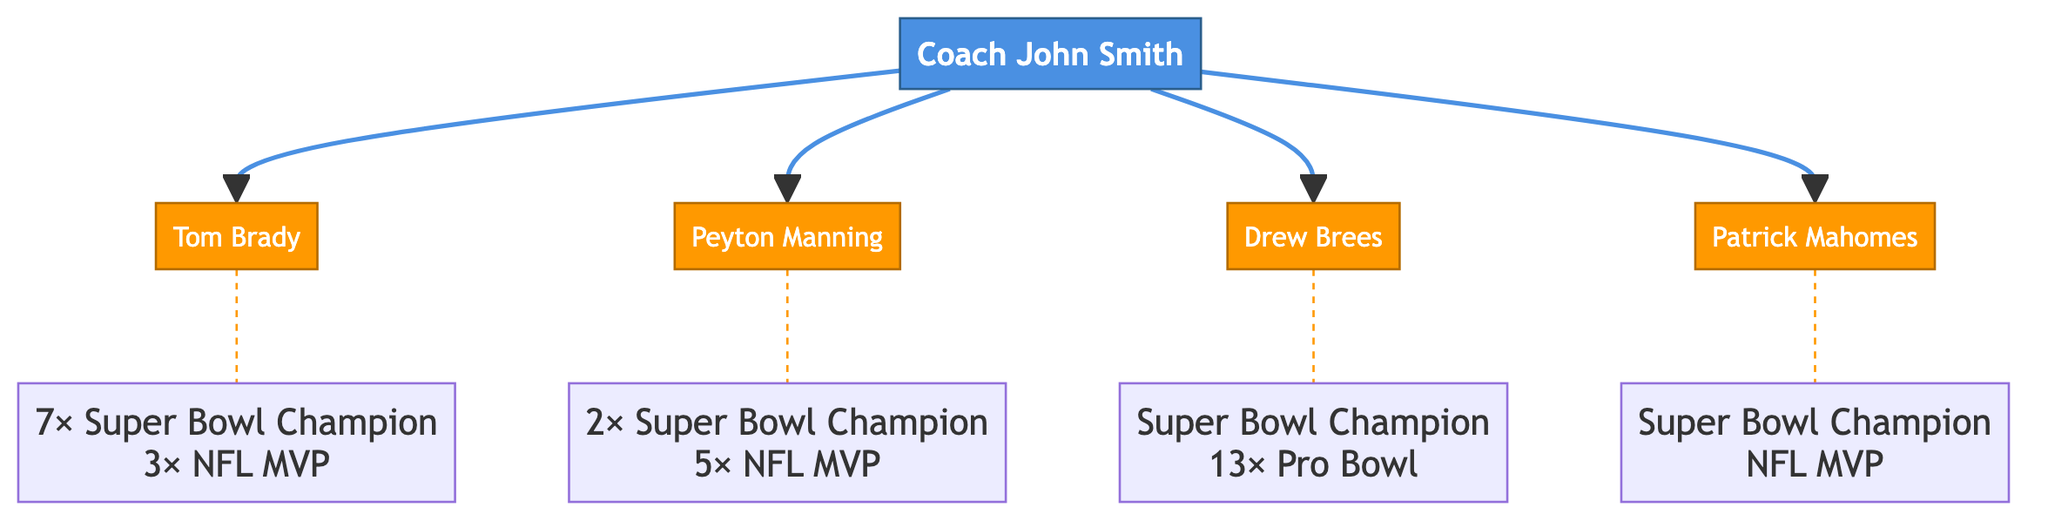What is the name of the coach at the top of the tree? The diagram shows "Coach John Smith" at the top as the root node.
Answer: Coach John Smith How many quarterbacks did Coach John Smith mentor? The diagram branches out from "Coach John Smith" to four quarterback nodes: Tom Brady, Peyton Manning, Drew Brees, and Patrick Mahomes. This gives a total of four mentored quarterbacks.
Answer: 4 Which quarterback has the most Super Bowl championships? Among the listed quarterbacks, Tom Brady is noted for having "7× Super Bowl Champion," which is the highest number of championships shown in the diagram.
Answer: Tom Brady What teams did Peyton Manning play for? The diagram indicates that Peyton Manning played for "Indianapolis Colts" and "Denver Broncos," which are both shown in his node.
Answer: Indianapolis Colts, Denver Broncos Which quarterback has the least number of Pro Bowl selections? The diagram shows that Drew Brees has "13× Pro Bowl" selections, while the other quarterbacks either have no direct measure provided or a higher count of championships or MVPs, suggesting he has the least among the known details.
Answer: Drew Brees How many times was Tom Brady named NFL MVP? The information in the diagram states that Tom Brady is a "3× NFL MVP," indicating the number of times he was awarded this title.
Answer: 3 Which quarterback was mentored by Coach John Smith and has won an MVP title? The diagram shows Patrick Mahomes with the label "NFL MVP," indicating he is the quarterback mentored by Coach John Smith who has won this title.
Answer: Patrick Mahomes What is a common achievement among all the quarterbacks in the diagram? All quarterbacks listed (Brady, Manning, Brees, Mahomes) have won a Super Bowl, as indicated by their respective nodes.
Answer: Super Bowl Champion 